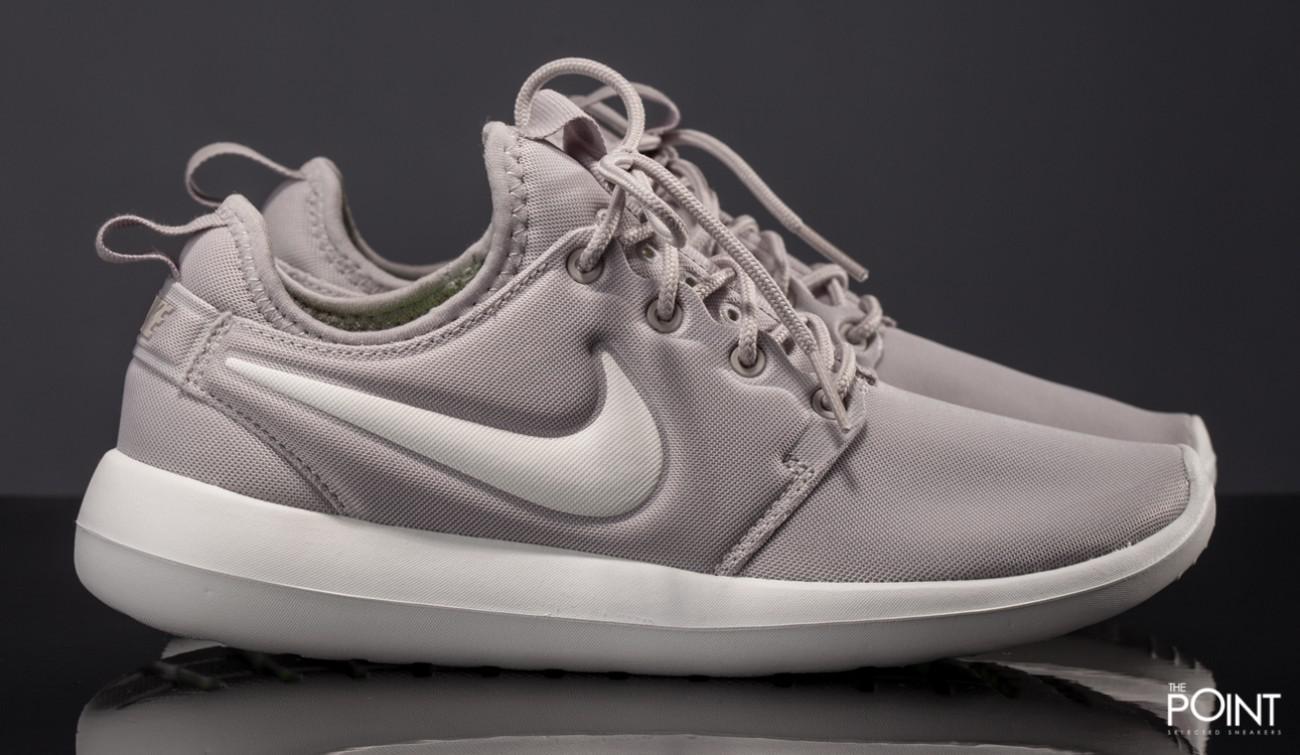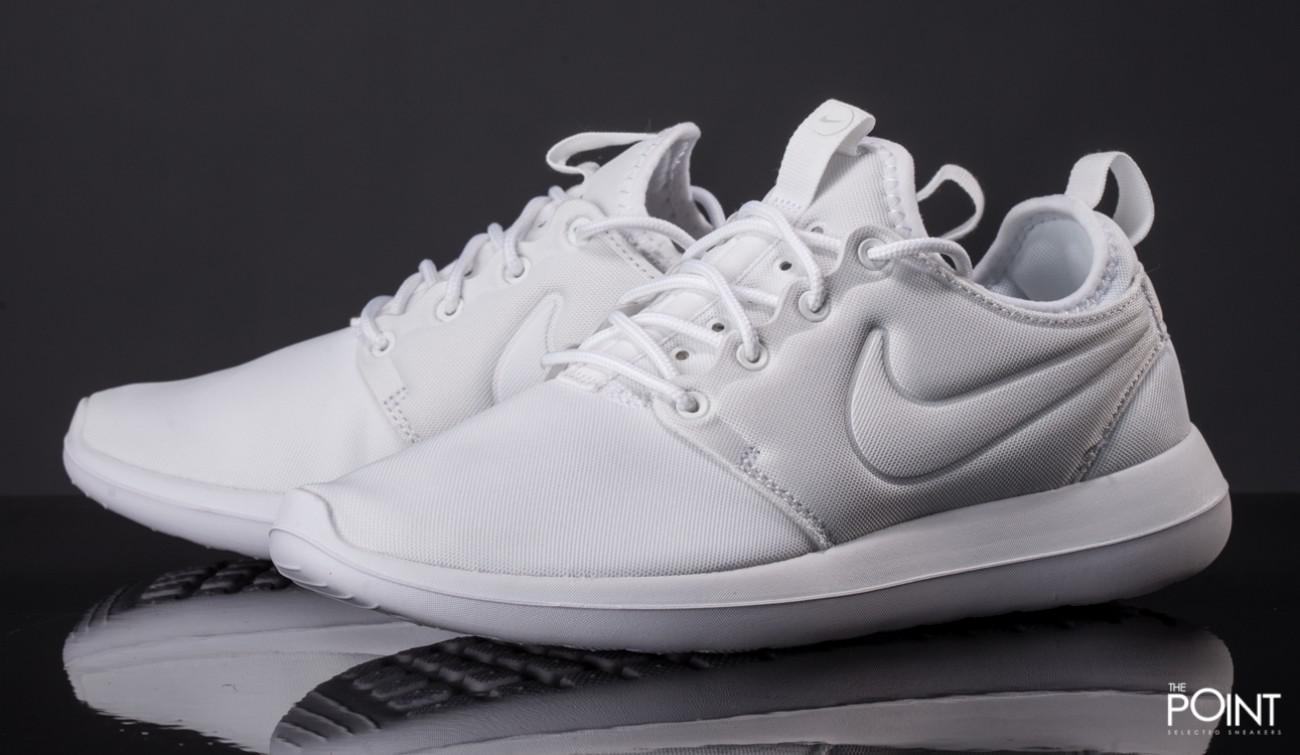The first image is the image on the left, the second image is the image on the right. Analyze the images presented: Is the assertion "Both images show a pair of grey sneakers that aren't currently worn by anyone." valid? Answer yes or no. No. The first image is the image on the left, the second image is the image on the right. Given the left and right images, does the statement "Each image contains one unworn, matched pair of sneakers posed soles-downward, and the sneakers in the left and right images face inward toward each other." hold true? Answer yes or no. Yes. 